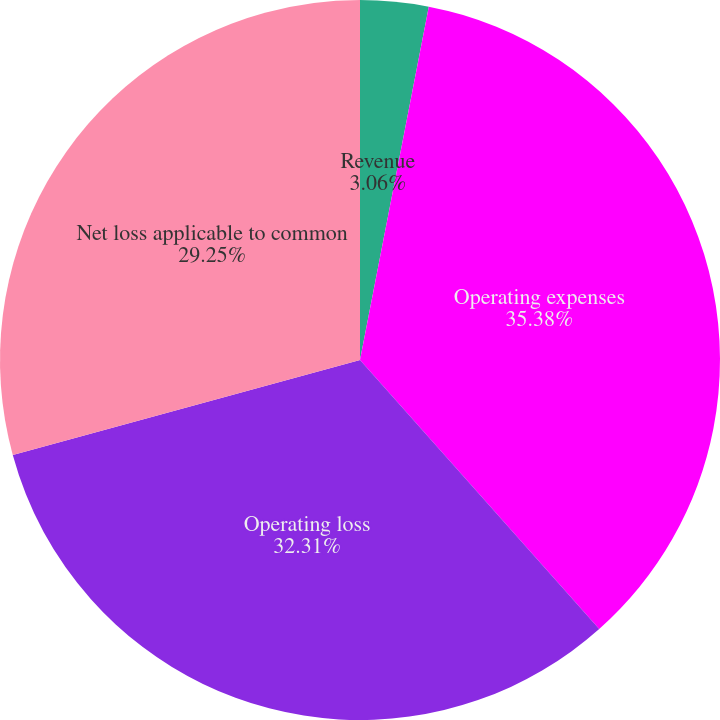Convert chart to OTSL. <chart><loc_0><loc_0><loc_500><loc_500><pie_chart><fcel>Revenue<fcel>Operating expenses<fcel>Operating loss<fcel>Net loss applicable to common<fcel>Net loss per common share<nl><fcel>3.06%<fcel>35.37%<fcel>32.31%<fcel>29.25%<fcel>0.0%<nl></chart> 